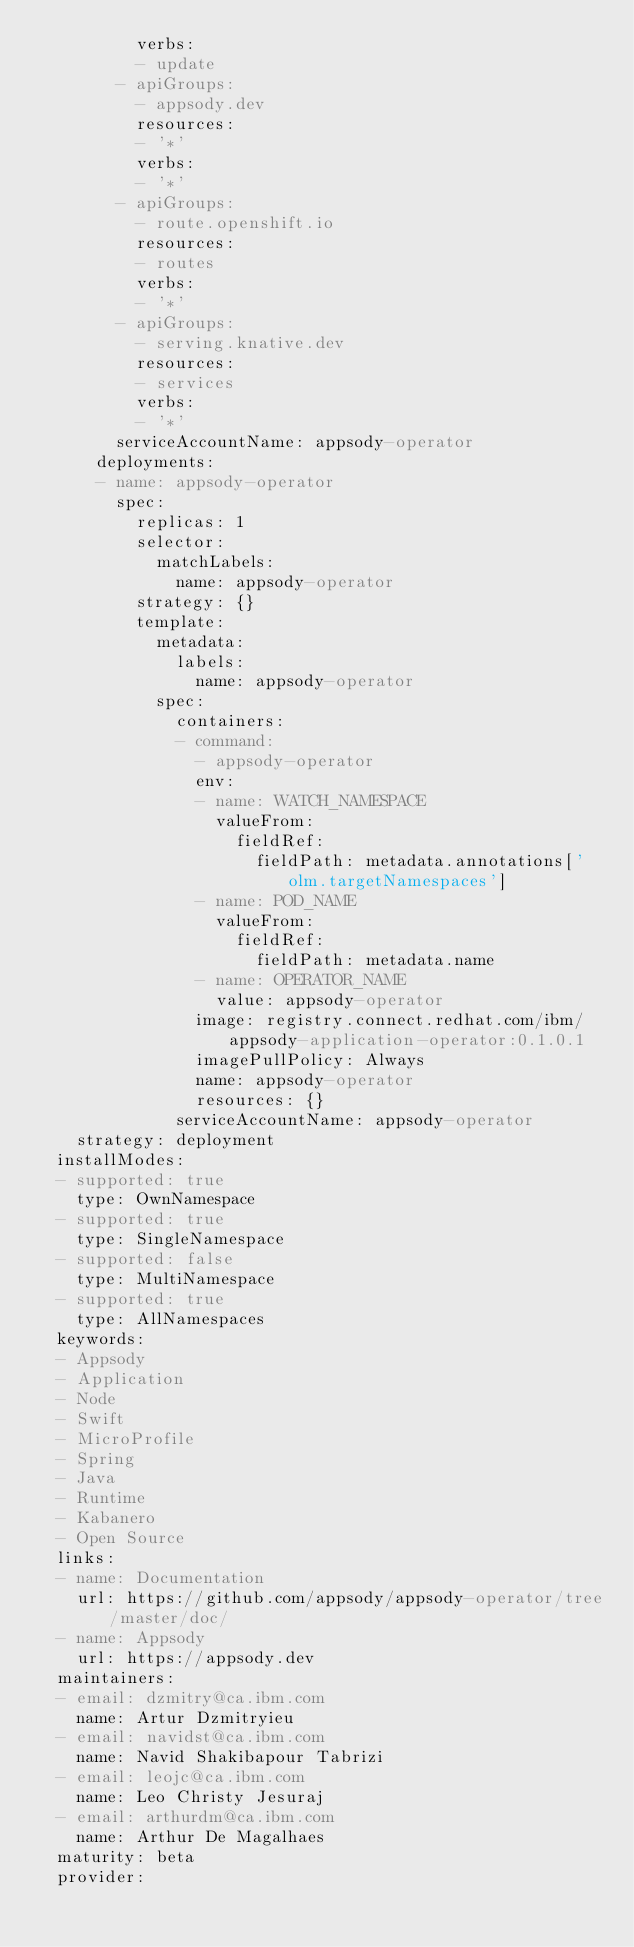Convert code to text. <code><loc_0><loc_0><loc_500><loc_500><_YAML_>          verbs:
          - update
        - apiGroups:
          - appsody.dev
          resources:
          - '*'
          verbs:
          - '*'
        - apiGroups:
          - route.openshift.io
          resources:
          - routes
          verbs:
          - '*'
        - apiGroups:
          - serving.knative.dev
          resources:
          - services
          verbs:
          - '*'
        serviceAccountName: appsody-operator
      deployments:
      - name: appsody-operator
        spec:
          replicas: 1
          selector:
            matchLabels:
              name: appsody-operator
          strategy: {}
          template:
            metadata:
              labels:
                name: appsody-operator
            spec:
              containers:
              - command:
                - appsody-operator
                env:
                - name: WATCH_NAMESPACE
                  valueFrom:
                    fieldRef:
                      fieldPath: metadata.annotations['olm.targetNamespaces']
                - name: POD_NAME
                  valueFrom:
                    fieldRef:
                      fieldPath: metadata.name
                - name: OPERATOR_NAME
                  value: appsody-operator
                image: registry.connect.redhat.com/ibm/appsody-application-operator:0.1.0.1
                imagePullPolicy: Always
                name: appsody-operator
                resources: {}
              serviceAccountName: appsody-operator
    strategy: deployment
  installModes:
  - supported: true
    type: OwnNamespace
  - supported: true
    type: SingleNamespace
  - supported: false
    type: MultiNamespace
  - supported: true
    type: AllNamespaces
  keywords:
  - Appsody
  - Application
  - Node
  - Swift
  - MicroProfile
  - Spring
  - Java
  - Runtime
  - Kabanero
  - Open Source
  links:
  - name: Documentation
    url: https://github.com/appsody/appsody-operator/tree/master/doc/
  - name: Appsody
    url: https://appsody.dev
  maintainers:
  - email: dzmitry@ca.ibm.com
    name: Artur Dzmitryieu
  - email: navidst@ca.ibm.com
    name: Navid Shakibapour Tabrizi
  - email: leojc@ca.ibm.com
    name: Leo Christy Jesuraj
  - email: arthurdm@ca.ibm.com
    name: Arthur De Magalhaes
  maturity: beta
  provider:</code> 